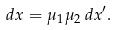Convert formula to latex. <formula><loc_0><loc_0><loc_500><loc_500>d x = \mu _ { 1 } \mu _ { 2 } \, d x ^ { \prime } .</formula> 